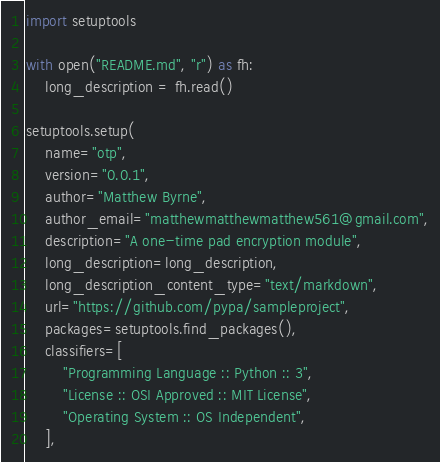Convert code to text. <code><loc_0><loc_0><loc_500><loc_500><_Python_>import setuptools

with open("README.md", "r") as fh:
    long_description = fh.read()

setuptools.setup(
    name="otp",
    version="0.0.1",
    author="Matthew Byrne",
    author_email="matthewmatthewmatthew561@gmail.com",
    description="A one-time pad encryption module",
    long_description=long_description,
    long_description_content_type="text/markdown",
    url="https://github.com/pypa/sampleproject",
    packages=setuptools.find_packages(),
    classifiers=[
        "Programming Language :: Python :: 3",
        "License :: OSI Approved :: MIT License",
        "Operating System :: OS Independent",
    ],
</code> 